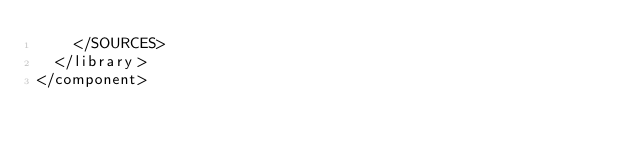Convert code to text. <code><loc_0><loc_0><loc_500><loc_500><_XML_>    </SOURCES>
  </library>
</component></code> 